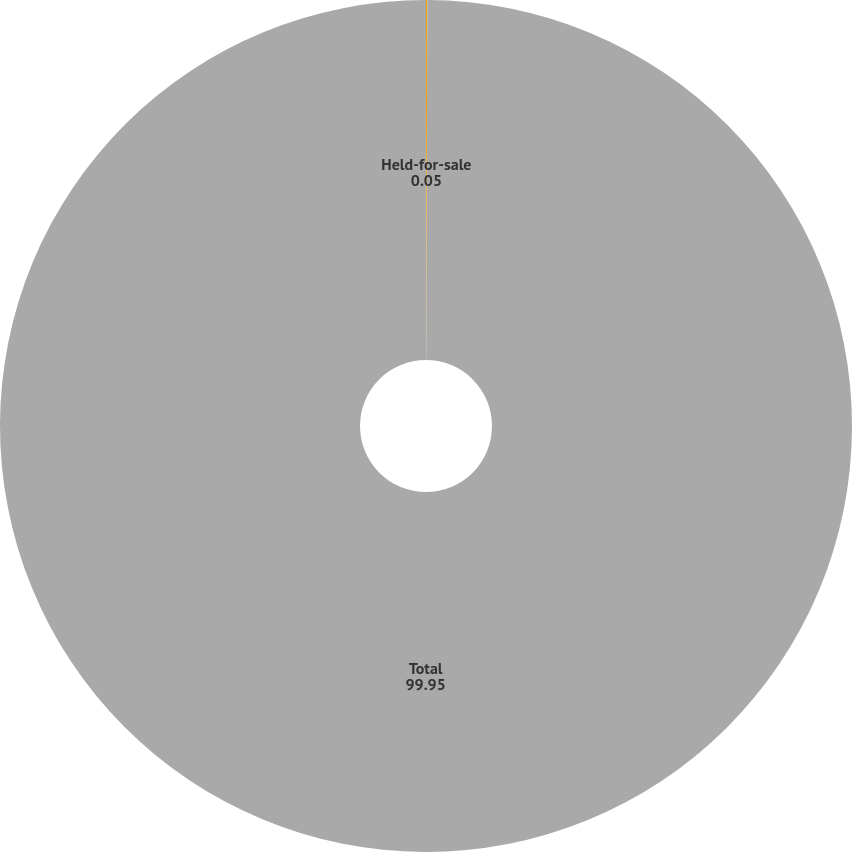Convert chart to OTSL. <chart><loc_0><loc_0><loc_500><loc_500><pie_chart><fcel>Held-for-sale<fcel>Total<nl><fcel>0.05%<fcel>99.95%<nl></chart> 